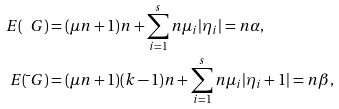<formula> <loc_0><loc_0><loc_500><loc_500>E ( \ G ) & = ( \mu n + 1 ) n + \sum _ { i = 1 } ^ { s } n \mu _ { i } | \eta _ { i } | = n \alpha , \\ E ( \bar { \ } G ) & = ( \mu n + 1 ) ( k - 1 ) n + \sum _ { i = 1 } ^ { s } n \mu _ { i } | \eta _ { i } + 1 | = n \beta ,</formula> 